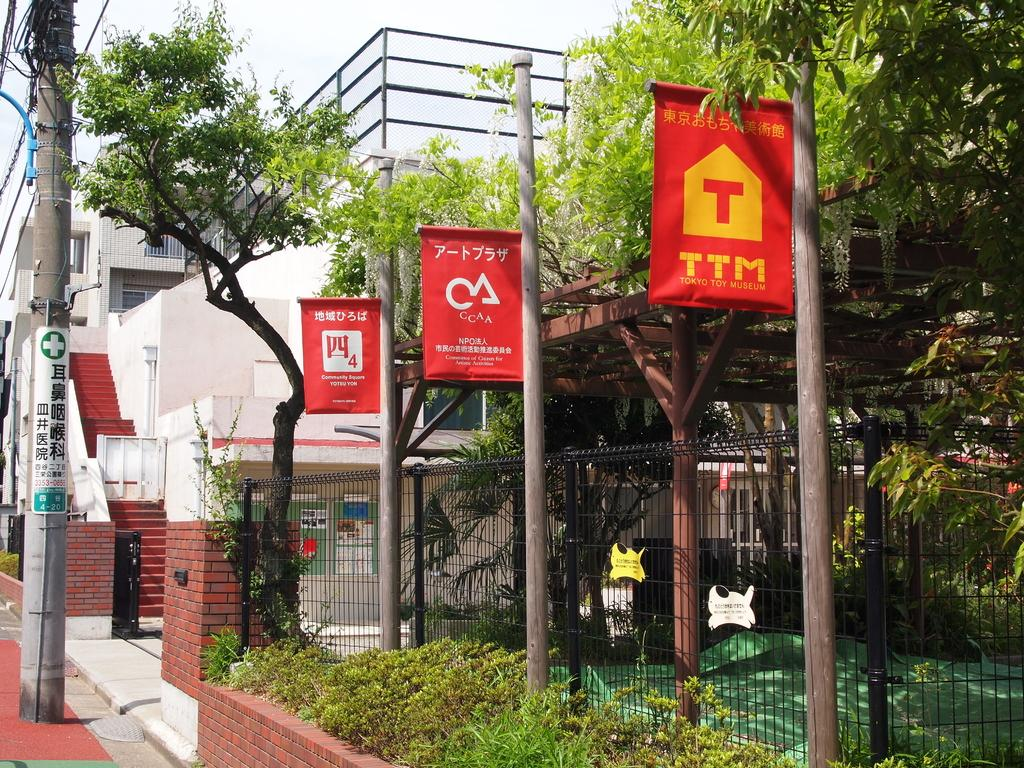What can be seen in the middle of the image? There are trees in the middle of the image. What structures are present in the image? There are poles, a fence, buildings, and electric poles in the image. What type of vegetation is visible in the image? There are plants in the image. What else can be seen on the poles in the image? There are cables in the image. What type of signage is present in the image? There are posters in the image. What part of the natural environment is visible in the image? The sky is visible in the image. What type of mine can be seen in the image? There is no mine present in the image. What type of soap is being used to clean the plants in the image? There is no soap or cleaning activity involving plants in the image. 